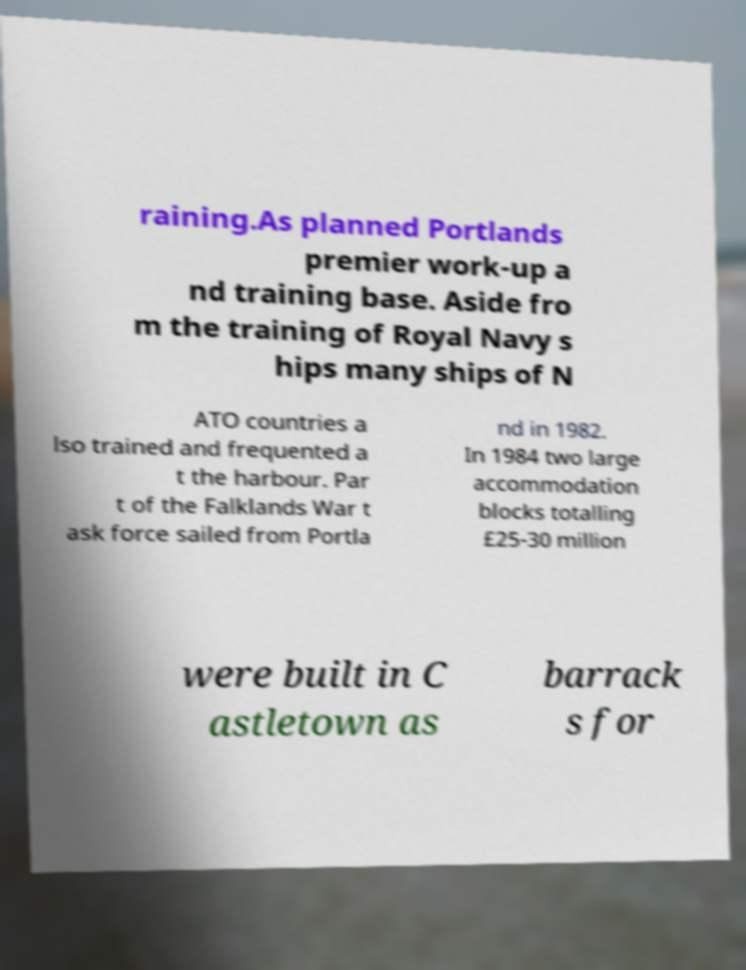Can you accurately transcribe the text from the provided image for me? raining.As planned Portlands premier work-up a nd training base. Aside fro m the training of Royal Navy s hips many ships of N ATO countries a lso trained and frequented a t the harbour. Par t of the Falklands War t ask force sailed from Portla nd in 1982. In 1984 two large accommodation blocks totalling £25-30 million were built in C astletown as barrack s for 